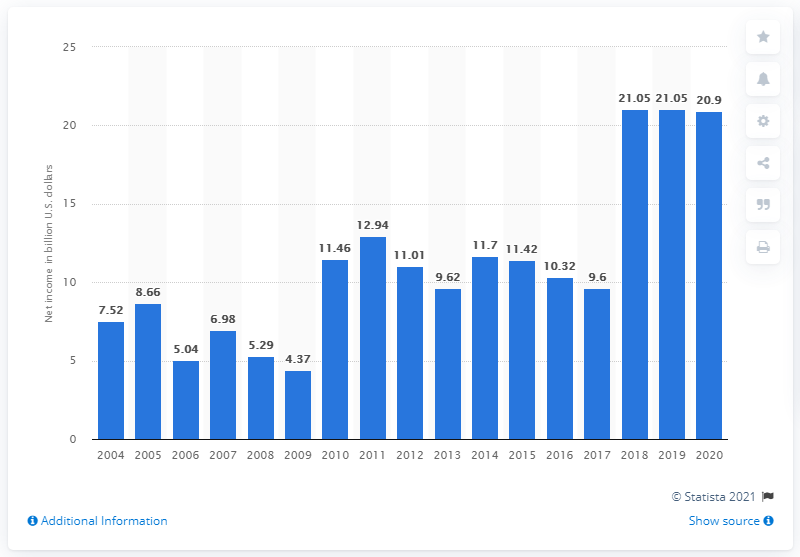Mention a couple of crucial points in this snapshot. In 2020, Intel's net income was 20.9 billion US dollars. In the previous year, the net income was 20.9 million dollars. 